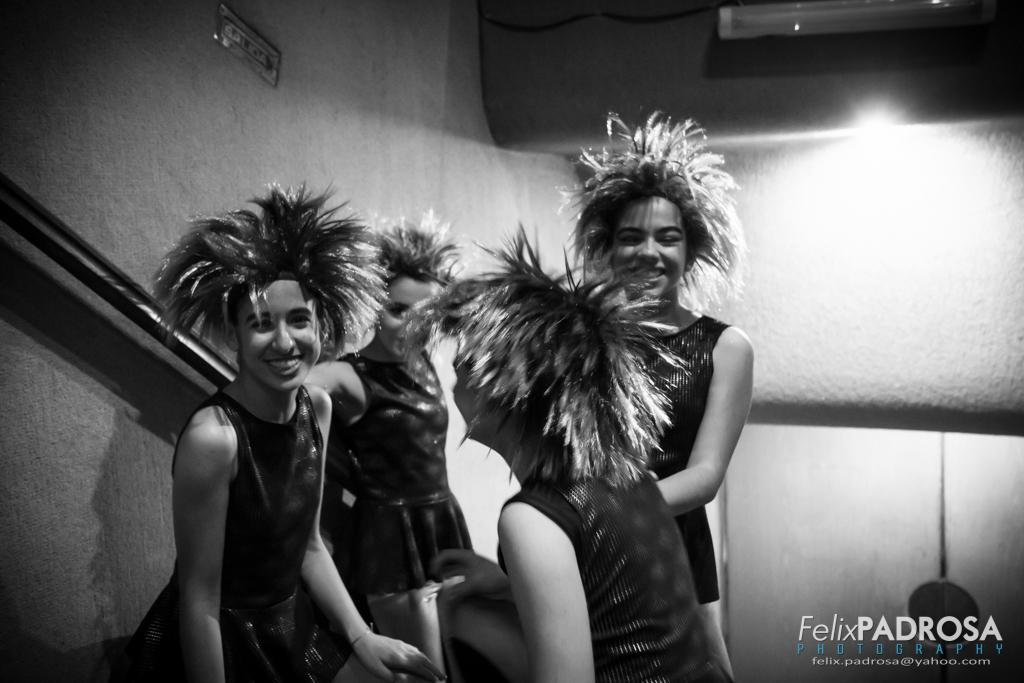How would you summarize this image in a sentence or two? In this image I can see the group of people with dresses and head wears. In the background I can see the light. And this is a black and white image. 